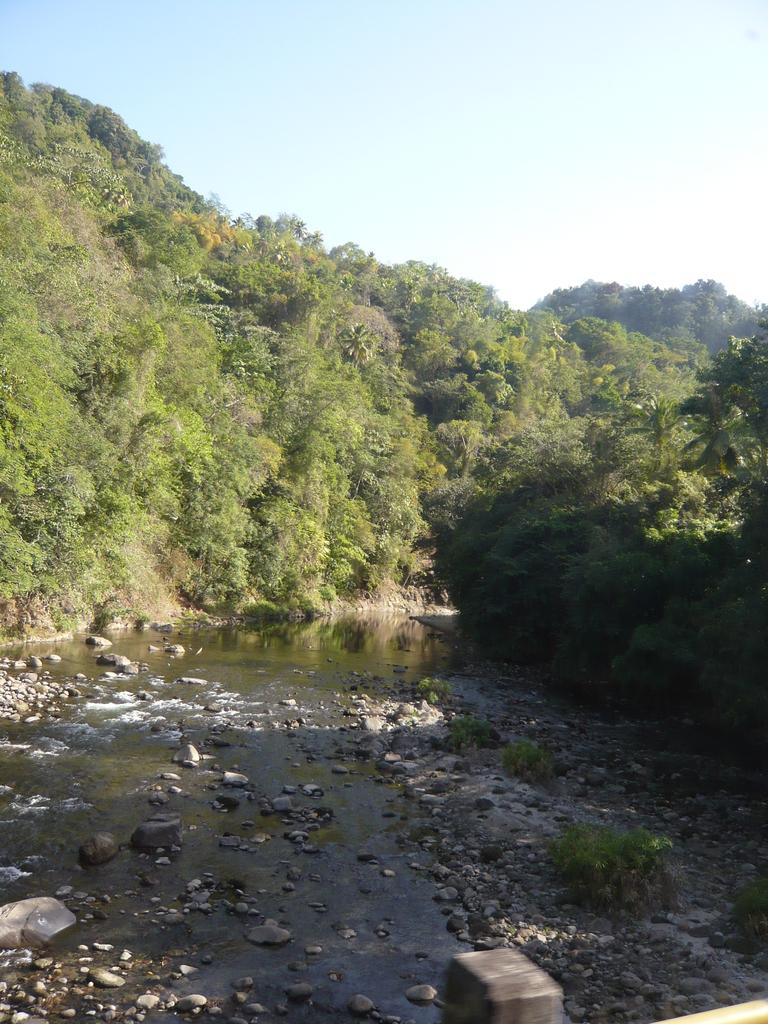What is located in the middle of the image? There is water in the middle of the image. What can be seen within the water in the image? There are stones in the water. What type of vegetation is visible in the background of the image? There are trees in the background of the image. What is visible at the top of the image? The sky is visible at the top of the image. How many geese are swimming in the water in the image? There are no geese present in the image; it only features water and stones. What type of bubble can be seen floating in the sky in the image? There is no bubble present in the image; only water, stones, trees, and the sky are visible. 